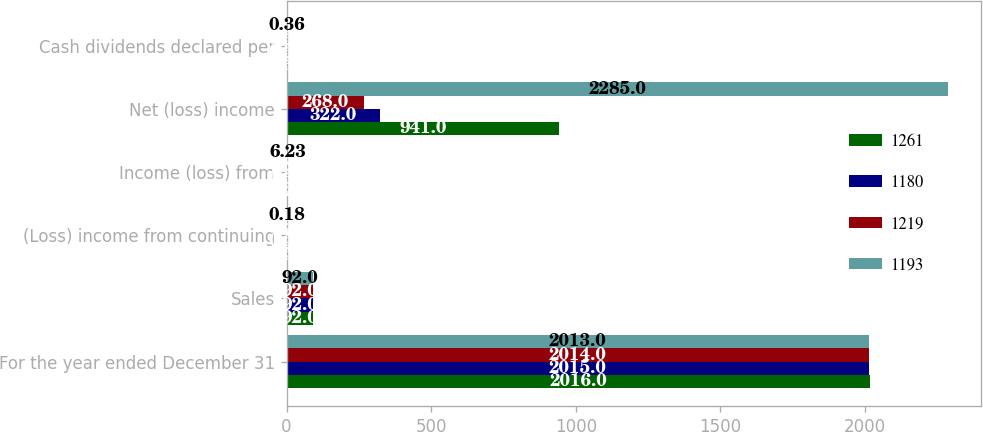Convert chart. <chart><loc_0><loc_0><loc_500><loc_500><stacked_bar_chart><ecel><fcel>For the year ended December 31<fcel>Sales<fcel>(Loss) income from continuing<fcel>Income (loss) from<fcel>Net (loss) income<fcel>Cash dividends declared per<nl><fcel>1261<fcel>2016<fcel>92<fcel>2.58<fcel>0.27<fcel>941<fcel>0.36<nl><fcel>1180<fcel>2015<fcel>92<fcel>0.54<fcel>0.39<fcel>322<fcel>0.36<nl><fcel>1219<fcel>2014<fcel>92<fcel>0.21<fcel>0.85<fcel>268<fcel>0.36<nl><fcel>1193<fcel>2013<fcel>92<fcel>0.18<fcel>6.23<fcel>2285<fcel>0.36<nl></chart> 